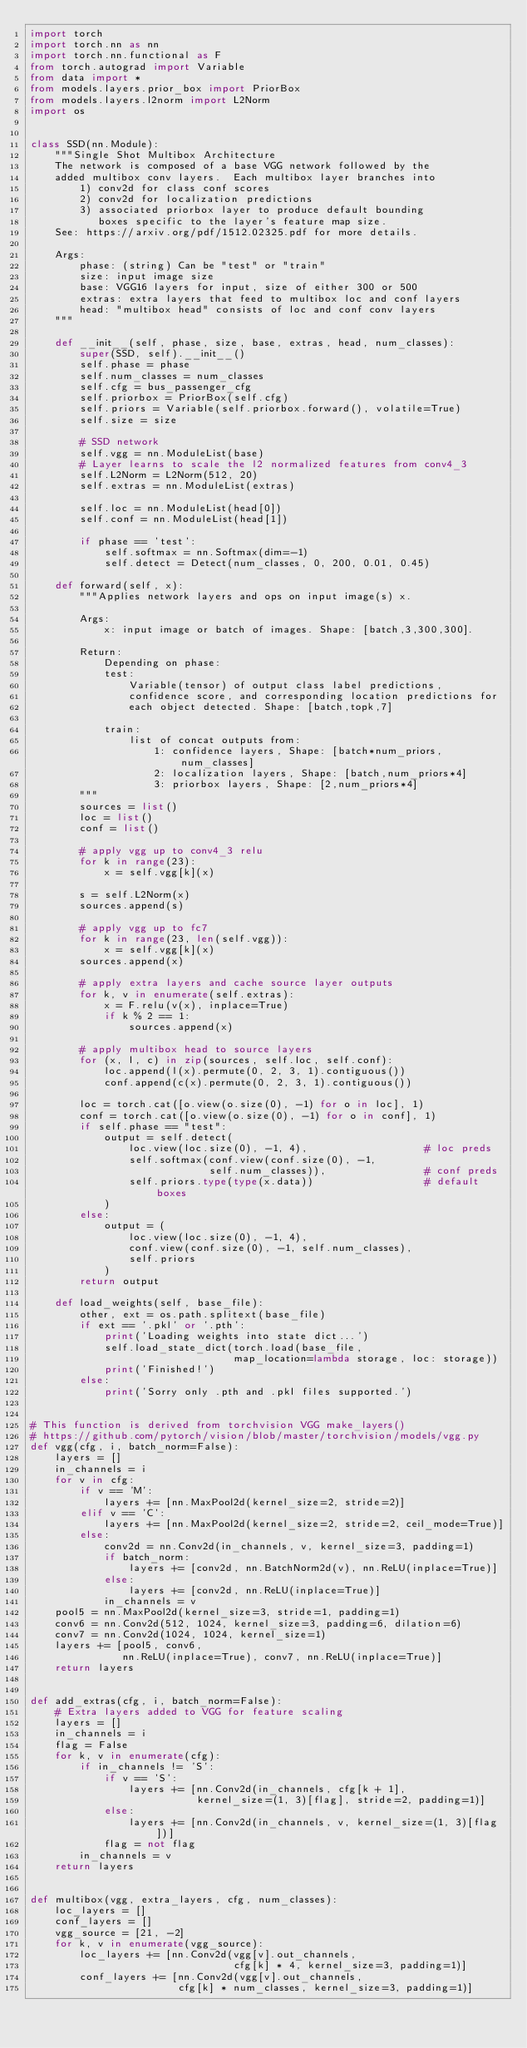<code> <loc_0><loc_0><loc_500><loc_500><_Python_>import torch
import torch.nn as nn
import torch.nn.functional as F
from torch.autograd import Variable
from data import *
from models.layers.prior_box import PriorBox
from models.layers.l2norm import L2Norm
import os


class SSD(nn.Module):
    """Single Shot Multibox Architecture
    The network is composed of a base VGG network followed by the
    added multibox conv layers.  Each multibox layer branches into
        1) conv2d for class conf scores
        2) conv2d for localization predictions
        3) associated priorbox layer to produce default bounding
           boxes specific to the layer's feature map size.
    See: https://arxiv.org/pdf/1512.02325.pdf for more details.

    Args:
        phase: (string) Can be "test" or "train"
        size: input image size
        base: VGG16 layers for input, size of either 300 or 500
        extras: extra layers that feed to multibox loc and conf layers
        head: "multibox head" consists of loc and conf conv layers
    """

    def __init__(self, phase, size, base, extras, head, num_classes):
        super(SSD, self).__init__()
        self.phase = phase
        self.num_classes = num_classes
        self.cfg = bus_passenger_cfg
        self.priorbox = PriorBox(self.cfg)
        self.priors = Variable(self.priorbox.forward(), volatile=True)
        self.size = size

        # SSD network
        self.vgg = nn.ModuleList(base)
        # Layer learns to scale the l2 normalized features from conv4_3
        self.L2Norm = L2Norm(512, 20)
        self.extras = nn.ModuleList(extras)

        self.loc = nn.ModuleList(head[0])
        self.conf = nn.ModuleList(head[1])

        if phase == 'test':
            self.softmax = nn.Softmax(dim=-1)
            self.detect = Detect(num_classes, 0, 200, 0.01, 0.45)

    def forward(self, x):
        """Applies network layers and ops on input image(s) x.

        Args:
            x: input image or batch of images. Shape: [batch,3,300,300].

        Return:
            Depending on phase:
            test:
                Variable(tensor) of output class label predictions,
                confidence score, and corresponding location predictions for
                each object detected. Shape: [batch,topk,7]

            train:
                list of concat outputs from:
                    1: confidence layers, Shape: [batch*num_priors,num_classes]
                    2: localization layers, Shape: [batch,num_priors*4]
                    3: priorbox layers, Shape: [2,num_priors*4]
        """
        sources = list()
        loc = list()
        conf = list()

        # apply vgg up to conv4_3 relu
        for k in range(23):
            x = self.vgg[k](x)

        s = self.L2Norm(x)
        sources.append(s)

        # apply vgg up to fc7
        for k in range(23, len(self.vgg)):
            x = self.vgg[k](x)
        sources.append(x)

        # apply extra layers and cache source layer outputs
        for k, v in enumerate(self.extras):
            x = F.relu(v(x), inplace=True)
            if k % 2 == 1:
                sources.append(x)

        # apply multibox head to source layers
        for (x, l, c) in zip(sources, self.loc, self.conf):
            loc.append(l(x).permute(0, 2, 3, 1).contiguous())
            conf.append(c(x).permute(0, 2, 3, 1).contiguous())

        loc = torch.cat([o.view(o.size(0), -1) for o in loc], 1)
        conf = torch.cat([o.view(o.size(0), -1) for o in conf], 1)
        if self.phase == "test":
            output = self.detect(
                loc.view(loc.size(0), -1, 4),                   # loc preds
                self.softmax(conf.view(conf.size(0), -1,
                             self.num_classes)),                # conf preds
                self.priors.type(type(x.data))                  # default boxes
            )
        else:
            output = (
                loc.view(loc.size(0), -1, 4),
                conf.view(conf.size(0), -1, self.num_classes),
                self.priors
            )
        return output

    def load_weights(self, base_file):
        other, ext = os.path.splitext(base_file)
        if ext == '.pkl' or '.pth':
            print('Loading weights into state dict...')
            self.load_state_dict(torch.load(base_file,
                                 map_location=lambda storage, loc: storage))
            print('Finished!')
        else:
            print('Sorry only .pth and .pkl files supported.')


# This function is derived from torchvision VGG make_layers()
# https://github.com/pytorch/vision/blob/master/torchvision/models/vgg.py
def vgg(cfg, i, batch_norm=False):
    layers = []
    in_channels = i
    for v in cfg:
        if v == 'M':
            layers += [nn.MaxPool2d(kernel_size=2, stride=2)]
        elif v == 'C':
            layers += [nn.MaxPool2d(kernel_size=2, stride=2, ceil_mode=True)]
        else:
            conv2d = nn.Conv2d(in_channels, v, kernel_size=3, padding=1)
            if batch_norm:
                layers += [conv2d, nn.BatchNorm2d(v), nn.ReLU(inplace=True)]
            else:
                layers += [conv2d, nn.ReLU(inplace=True)]
            in_channels = v
    pool5 = nn.MaxPool2d(kernel_size=3, stride=1, padding=1)
    conv6 = nn.Conv2d(512, 1024, kernel_size=3, padding=6, dilation=6)
    conv7 = nn.Conv2d(1024, 1024, kernel_size=1)
    layers += [pool5, conv6,
               nn.ReLU(inplace=True), conv7, nn.ReLU(inplace=True)]
    return layers


def add_extras(cfg, i, batch_norm=False):
    # Extra layers added to VGG for feature scaling
    layers = []
    in_channels = i
    flag = False
    for k, v in enumerate(cfg):
        if in_channels != 'S':
            if v == 'S':
                layers += [nn.Conv2d(in_channels, cfg[k + 1],
                           kernel_size=(1, 3)[flag], stride=2, padding=1)]
            else:
                layers += [nn.Conv2d(in_channels, v, kernel_size=(1, 3)[flag])]
            flag = not flag
        in_channels = v
    return layers


def multibox(vgg, extra_layers, cfg, num_classes):
    loc_layers = []
    conf_layers = []
    vgg_source = [21, -2]
    for k, v in enumerate(vgg_source):
        loc_layers += [nn.Conv2d(vgg[v].out_channels,
                                 cfg[k] * 4, kernel_size=3, padding=1)]
        conf_layers += [nn.Conv2d(vgg[v].out_channels,
                        cfg[k] * num_classes, kernel_size=3, padding=1)]</code> 